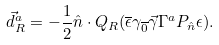<formula> <loc_0><loc_0><loc_500><loc_500>\vec { d } _ { R } ^ { a } = - \frac { 1 } { 2 } \hat { n } \cdot Q _ { R } ( \overline { \epsilon } \gamma _ { \overline { 0 } } \vec { \gamma } \Gamma ^ { a } P _ { \hat { n } } \epsilon ) .</formula> 